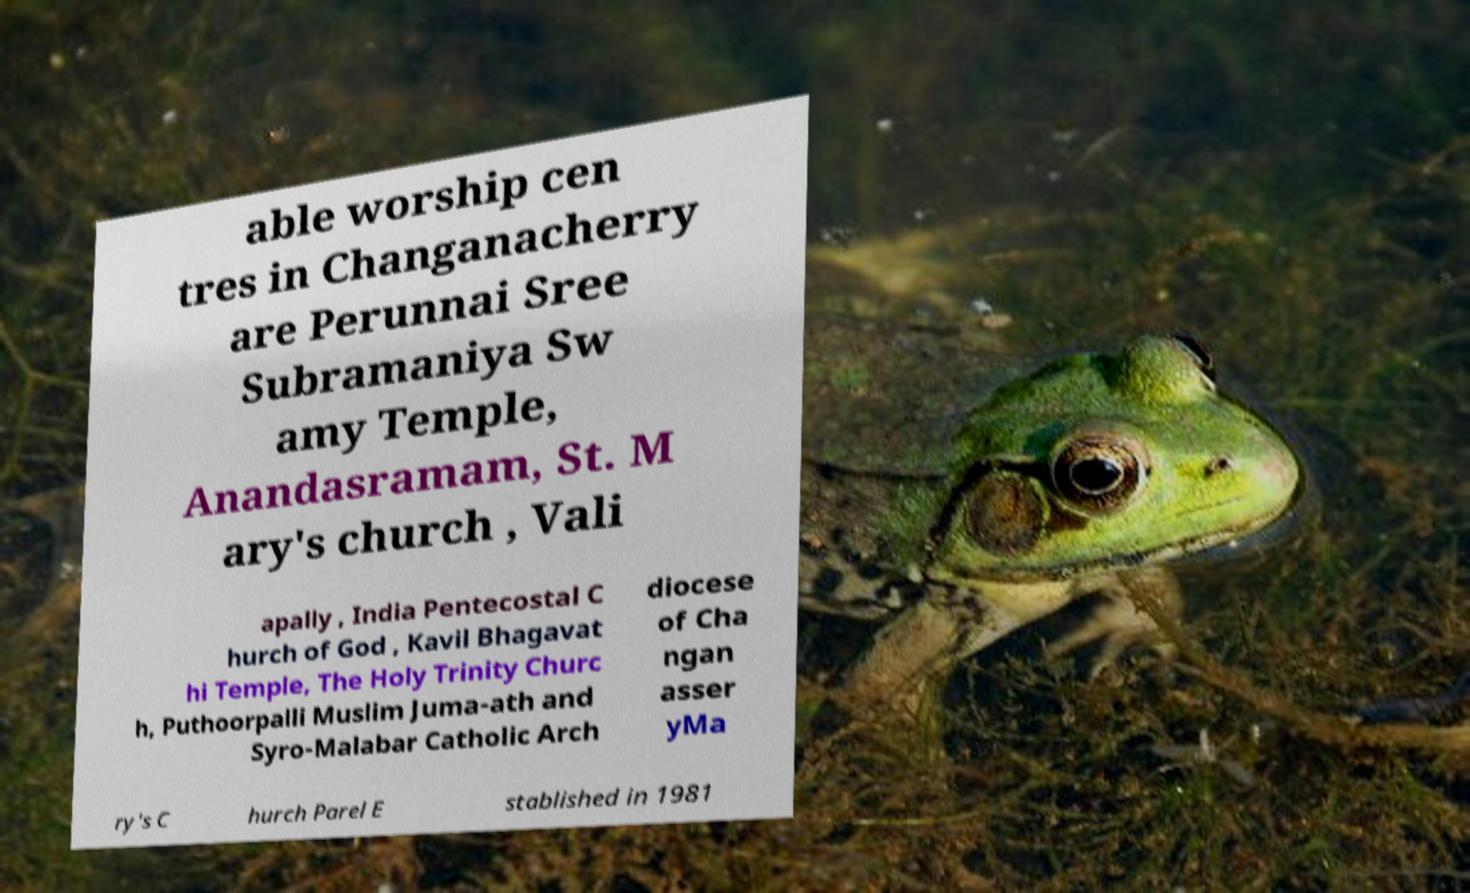Please identify and transcribe the text found in this image. able worship cen tres in Changanacherry are Perunnai Sree Subramaniya Sw amy Temple, Anandasramam, St. M ary's church , Vali apally , India Pentecostal C hurch of God , Kavil Bhagavat hi Temple, The Holy Trinity Churc h, Puthoorpalli Muslim Juma-ath and Syro-Malabar Catholic Arch diocese of Cha ngan asser yMa ry's C hurch Parel E stablished in 1981 